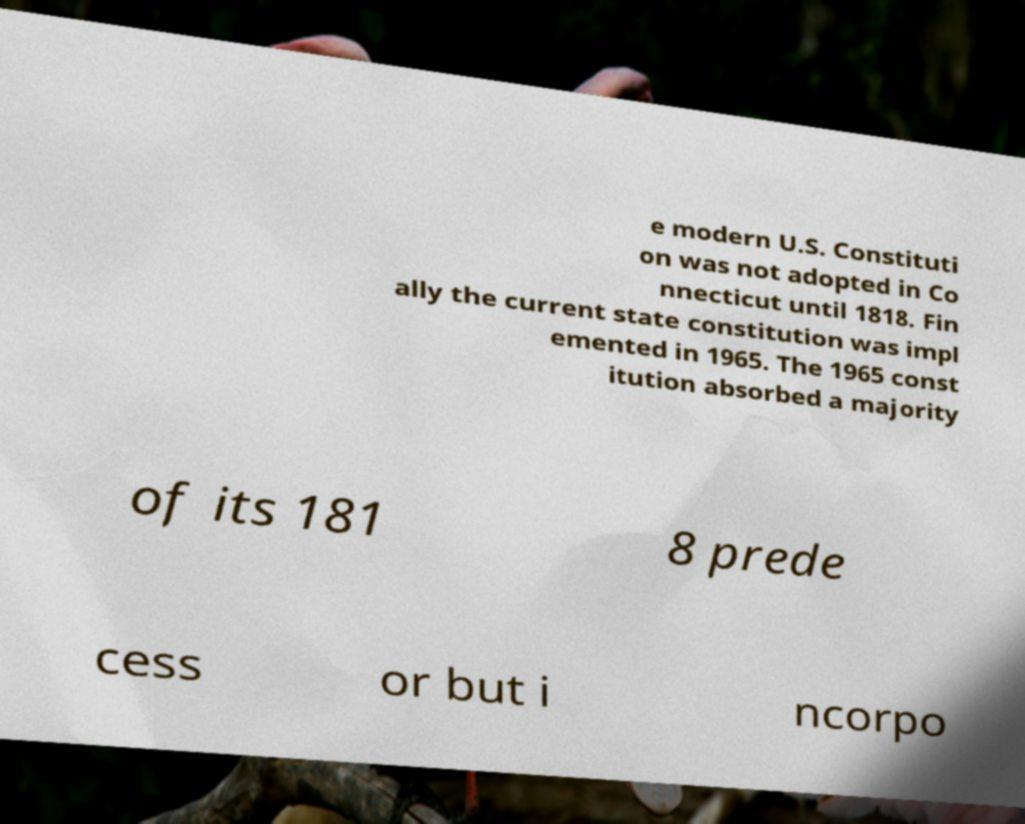Please read and relay the text visible in this image. What does it say? e modern U.S. Constituti on was not adopted in Co nnecticut until 1818. Fin ally the current state constitution was impl emented in 1965. The 1965 const itution absorbed a majority of its 181 8 prede cess or but i ncorpo 